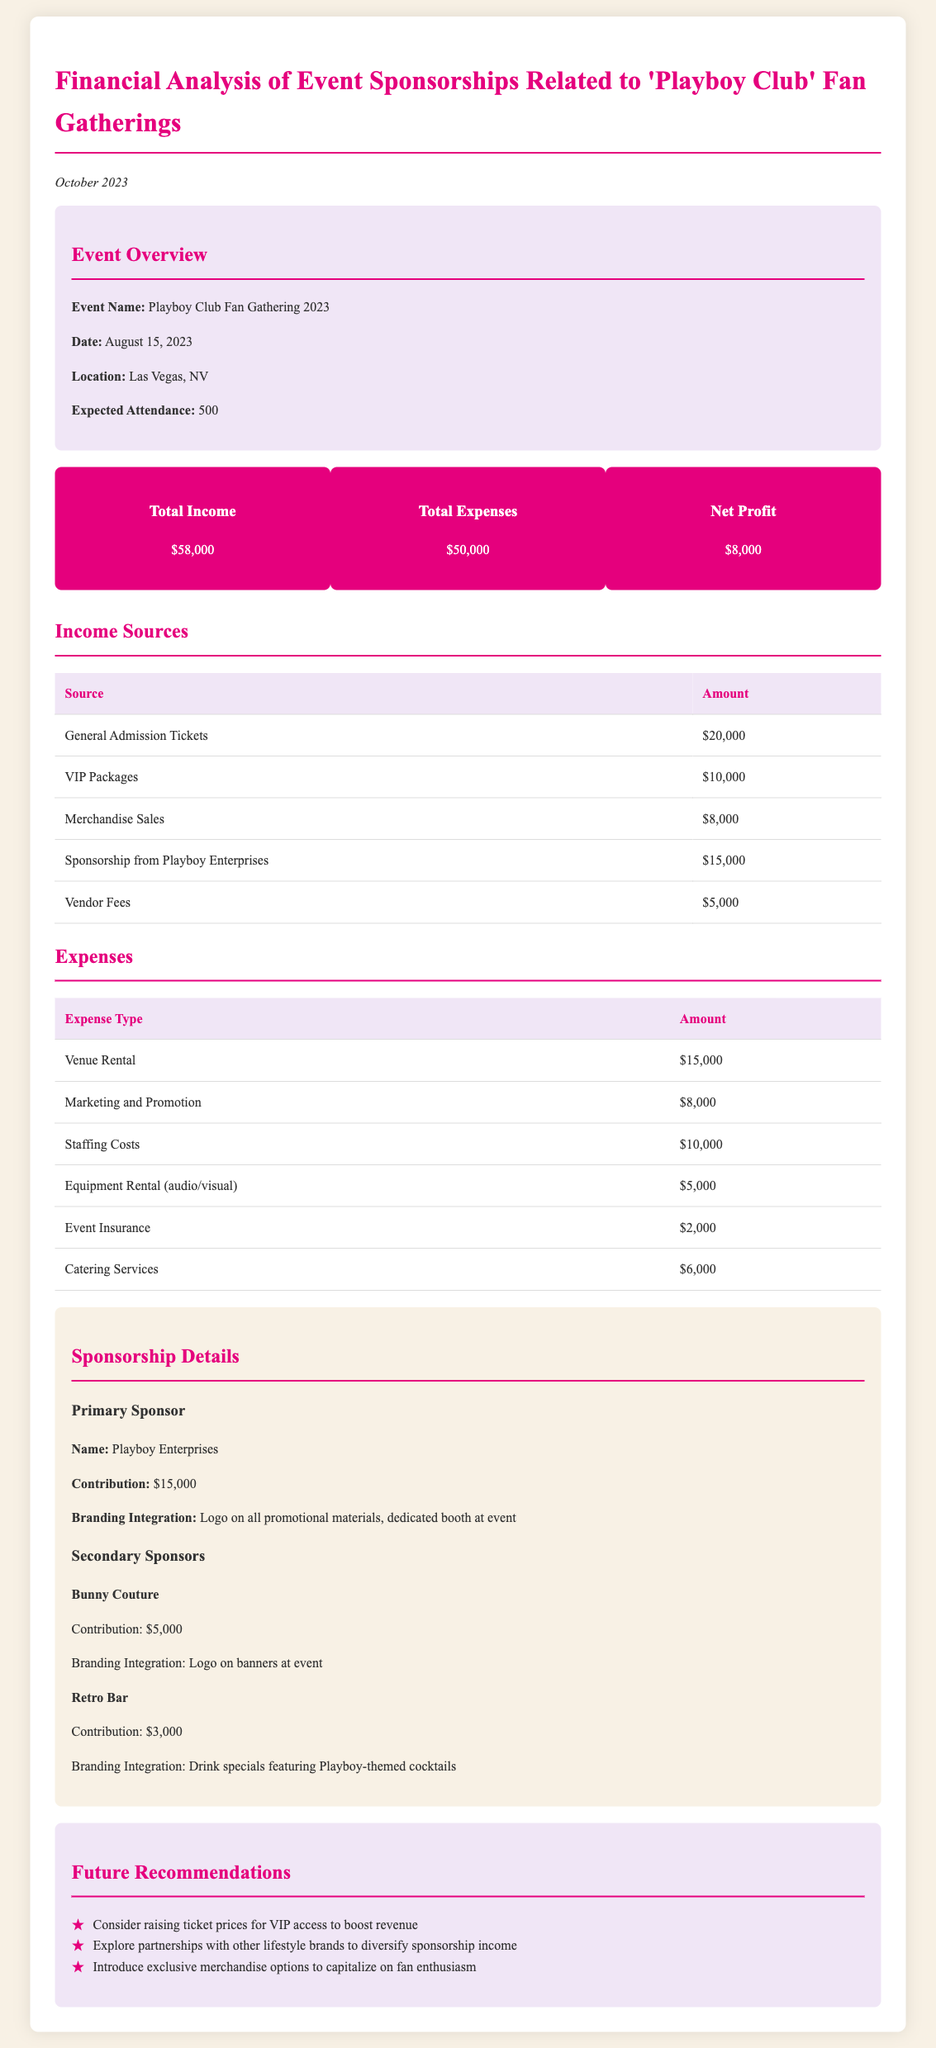What is the total income? The total income is stated in the financial summary section of the document.
Answer: $58,000 What was the event date? The event date is mentioned in the event overview section.
Answer: August 15, 2023 Who is the primary sponsor? The primary sponsor's name is provided in the sponsorship details section.
Answer: Playboy Enterprises What were the total expenses? The total expenses can be found in the financial summary section of the document.
Answer: $50,000 What is the net profit from the event? The net profit is derived from the financial summary provided in the document.
Answer: $8,000 How much was contributed by Bunny Couture? The contribution from Bunny Couture is detailed in the sponsorship section.
Answer: $5,000 What was the expected attendance? The expected attendance is listed in the event overview section.
Answer: 500 Which expense type had the highest cost? The expense type with the highest cost can be found in the expenses table.
Answer: Venue Rental What are the recommendations for future events? The recommendations are outlined in the future recommendations section of the document.
Answer: Raise ticket prices for VIP access What was the contribution from vendor fees? The contribution from vendor fees is specified in the income sources table.
Answer: $5,000 